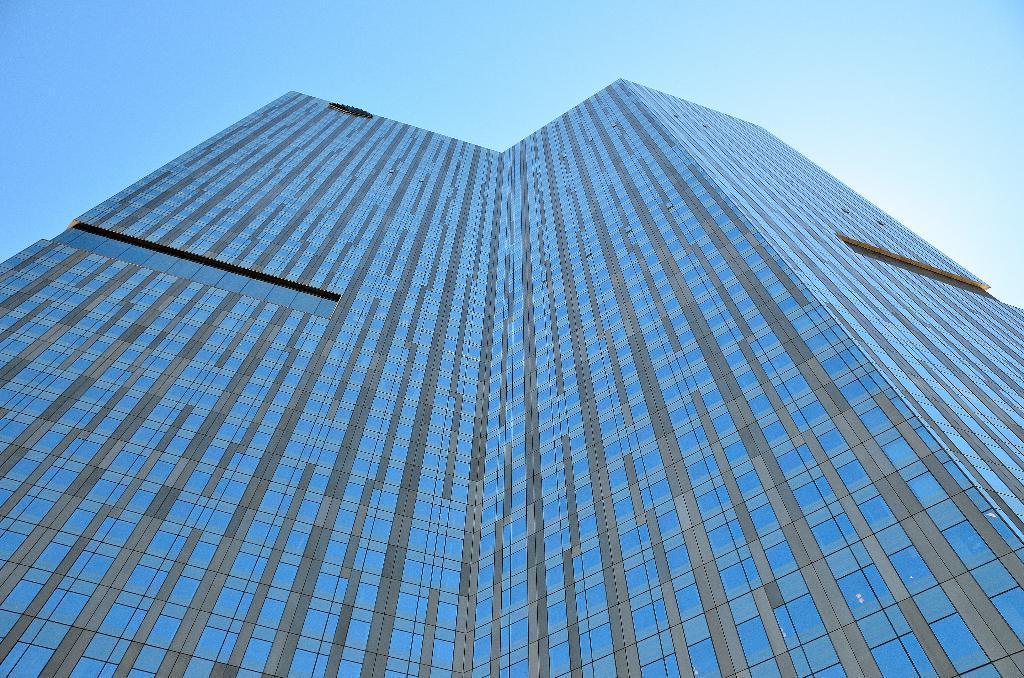In one or two sentences, can you explain what this image depicts? In this image in the center there is a building, and at the top there is sky. 